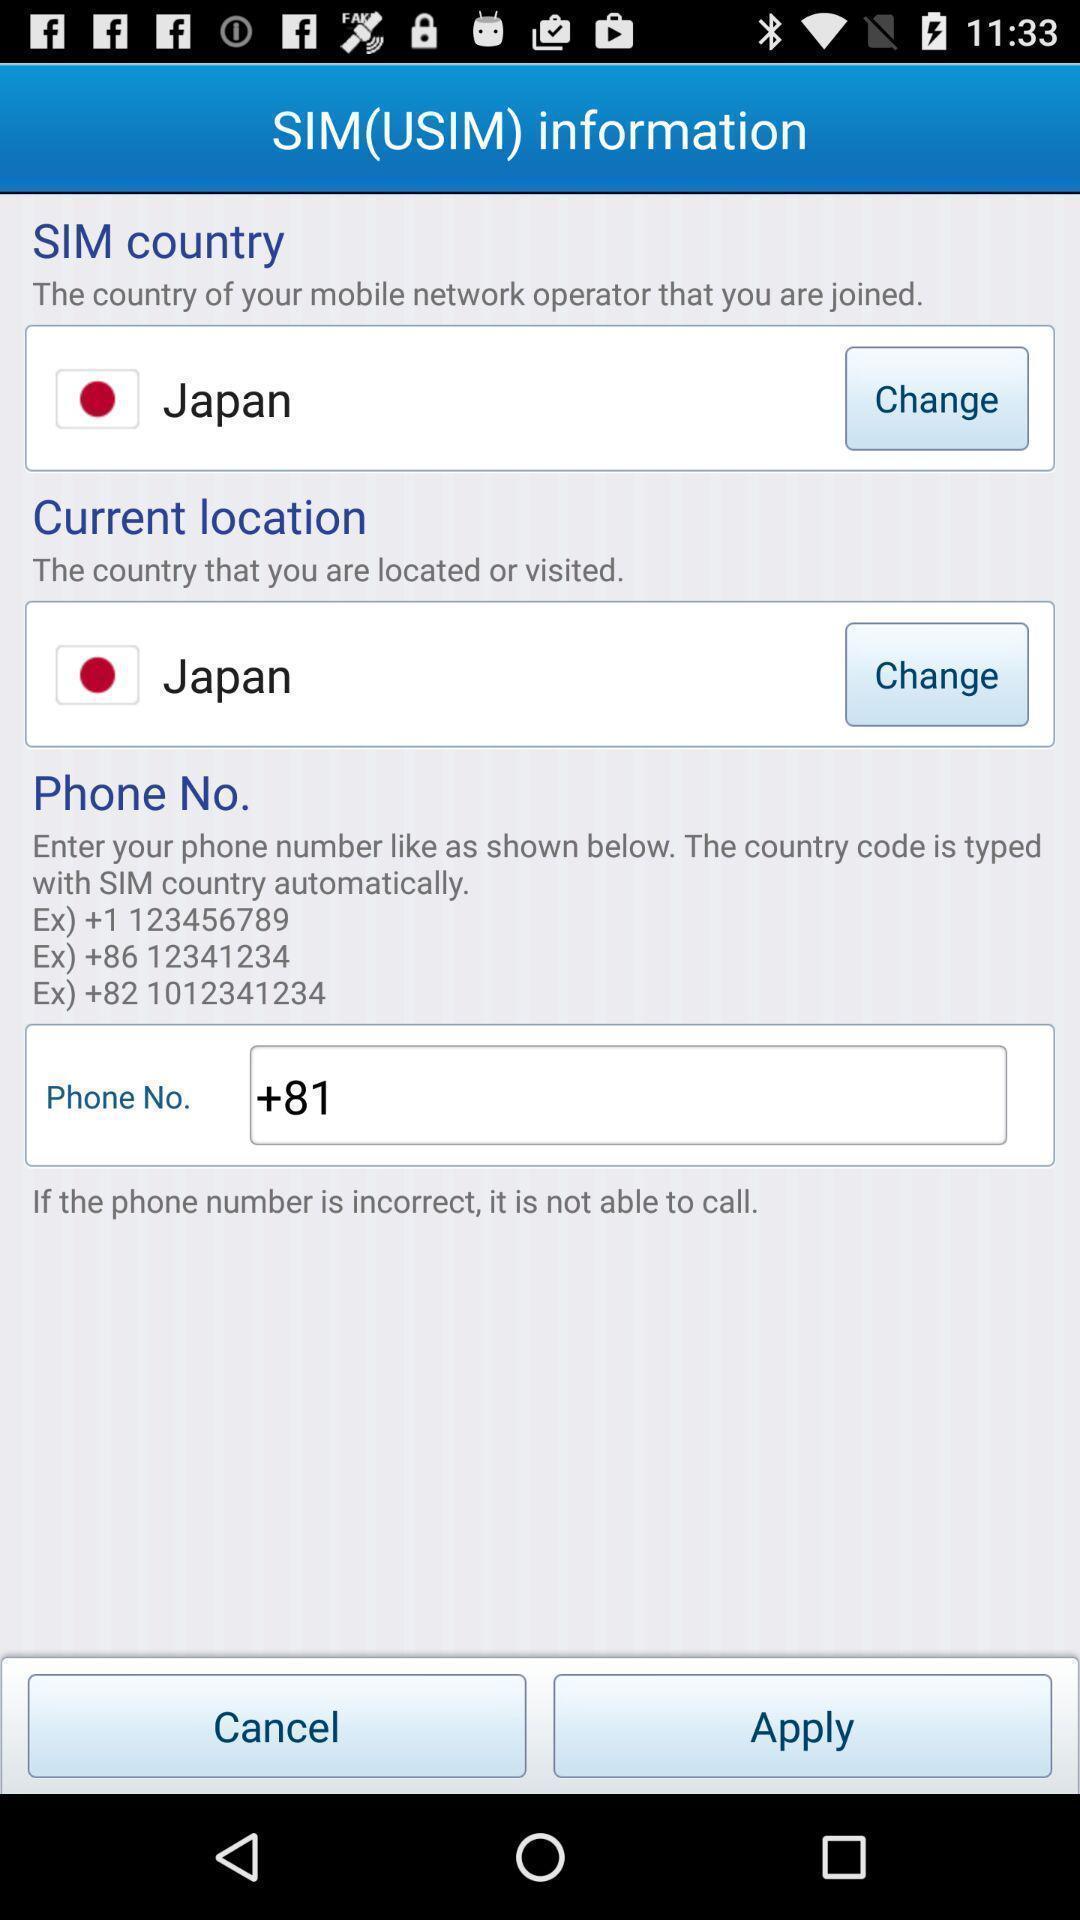Provide a description of this screenshot. Screen displaying information of sim. 